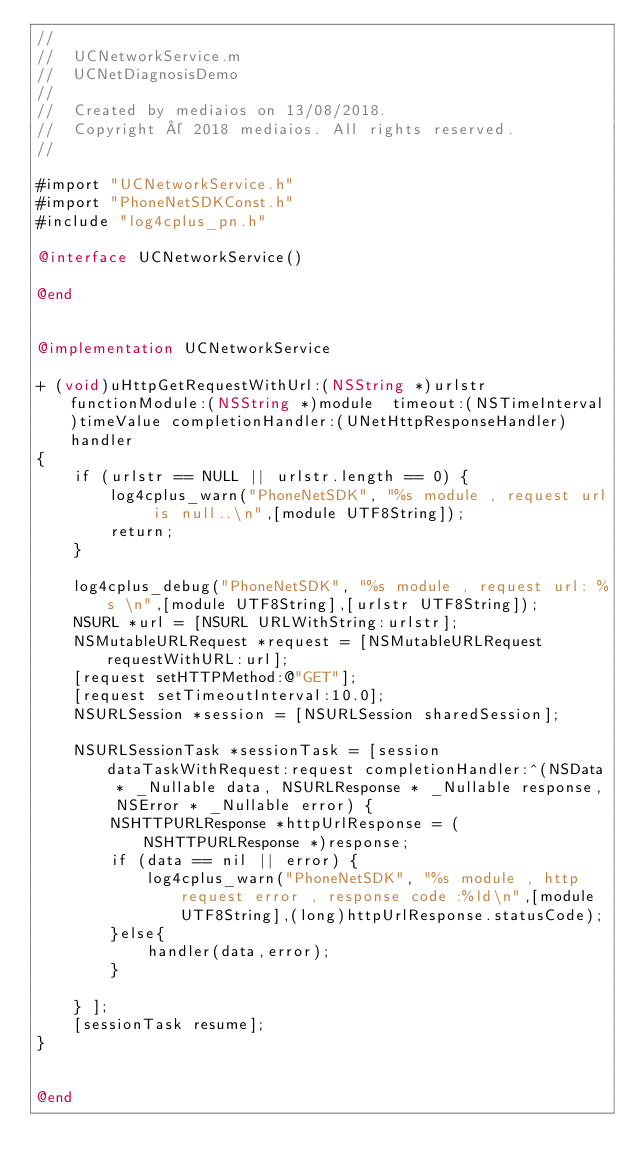Convert code to text. <code><loc_0><loc_0><loc_500><loc_500><_ObjectiveC_>//
//  UCNetworkService.m
//  UCNetDiagnosisDemo
//
//  Created by mediaios on 13/08/2018.
//  Copyright © 2018 mediaios. All rights reserved.
//

#import "UCNetworkService.h"
#import "PhoneNetSDKConst.h"
#include "log4cplus_pn.h"

@interface UCNetworkService()

@end


@implementation UCNetworkService

+ (void)uHttpGetRequestWithUrl:(NSString *)urlstr functionModule:(NSString *)module  timeout:(NSTimeInterval)timeValue completionHandler:(UNetHttpResponseHandler)handler
{
    if (urlstr == NULL || urlstr.length == 0) {
        log4cplus_warn("PhoneNetSDK", "%s module , request url is null..\n",[module UTF8String]);
        return;
    }
    
    log4cplus_debug("PhoneNetSDK", "%s module , request url: %s \n",[module UTF8String],[urlstr UTF8String]);
    NSURL *url = [NSURL URLWithString:urlstr];
    NSMutableURLRequest *request = [NSMutableURLRequest requestWithURL:url];
    [request setHTTPMethod:@"GET"];
    [request setTimeoutInterval:10.0];
    NSURLSession *session = [NSURLSession sharedSession];
    
    NSURLSessionTask *sessionTask = [session dataTaskWithRequest:request completionHandler:^(NSData * _Nullable data, NSURLResponse * _Nullable response, NSError * _Nullable error) {
        NSHTTPURLResponse *httpUrlResponse = (NSHTTPURLResponse *)response;
        if (data == nil || error) {
            log4cplus_warn("PhoneNetSDK", "%s module , http request error , response code :%ld\n",[module UTF8String],(long)httpUrlResponse.statusCode);
        }else{
            handler(data,error);
        }
        
    } ];
    [sessionTask resume];
}


@end
</code> 